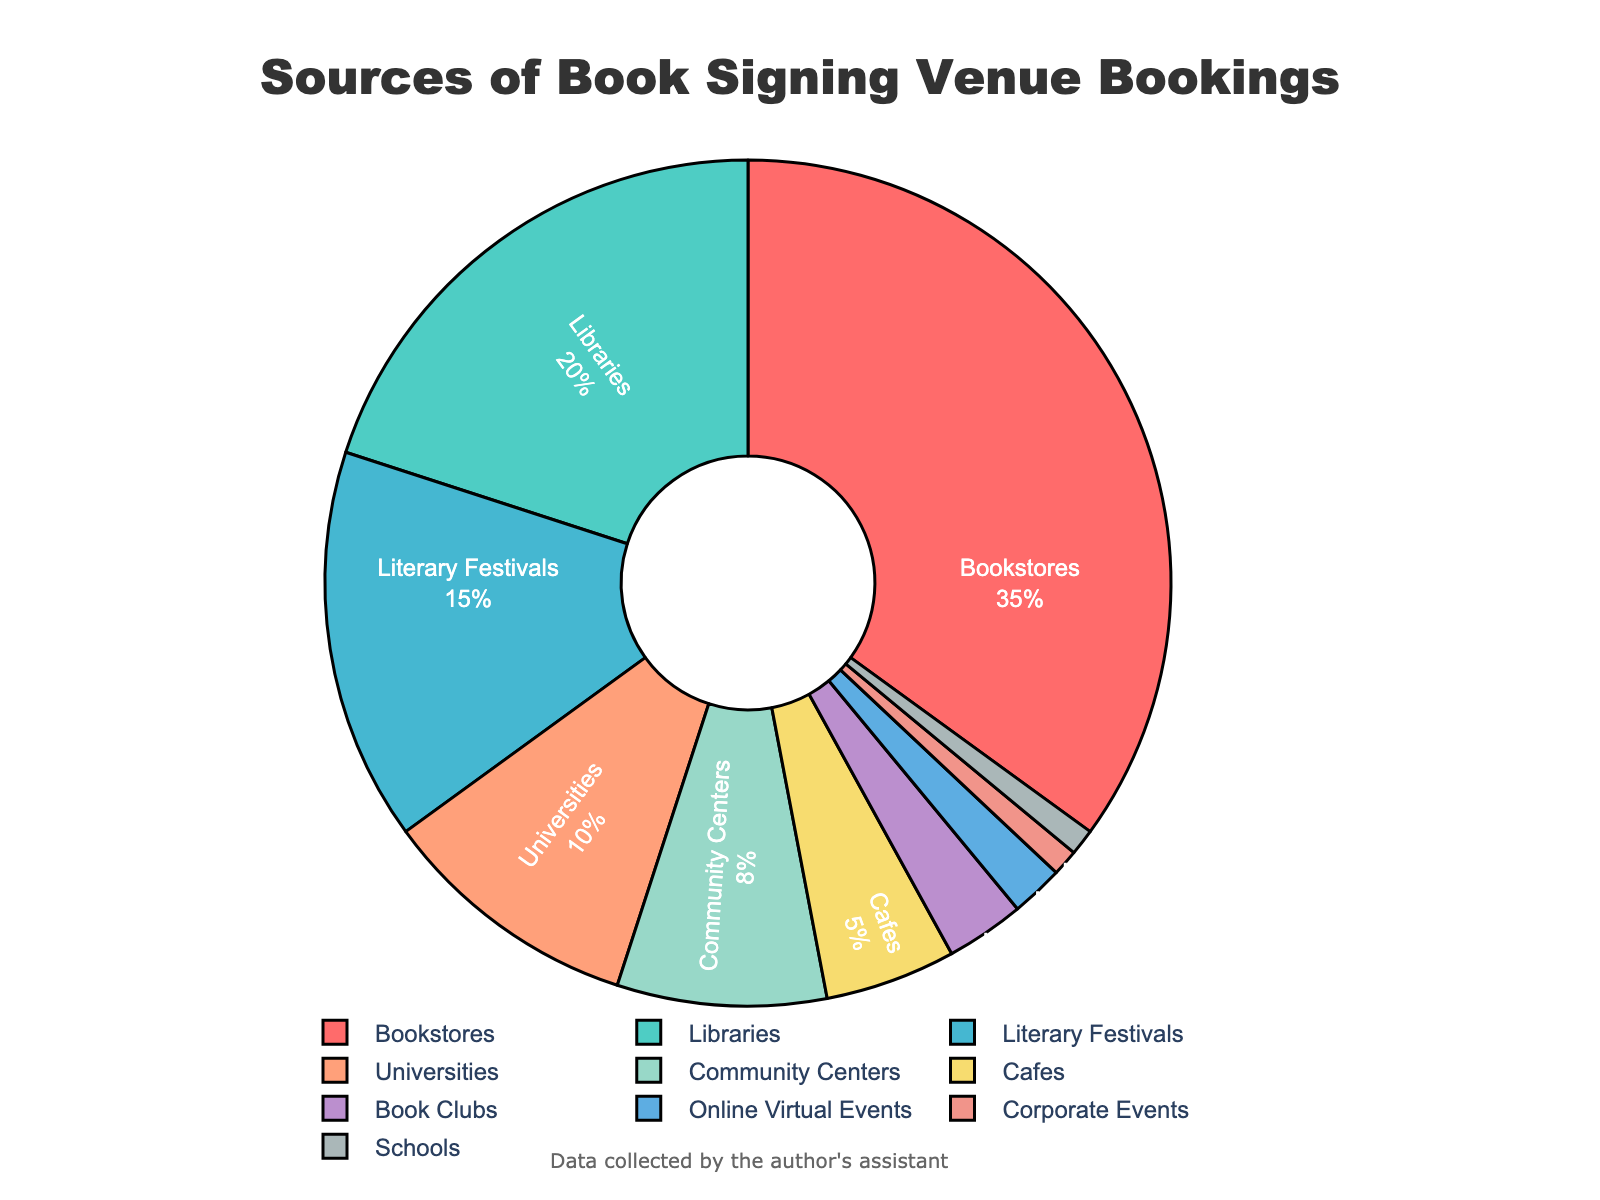What percentage of bookings is from libraries and community centers combined? Add the percentages for libraries (20%) and community centers (8%). 20 + 8 = 28
Answer: 28% Which source of venue bookings has the highest percentage? Look for the category with the largest percentage value; bookstores have the highest percentage at 35%.
Answer: Bookstores How does the percentage of bookings from literary festivals compare to those from universities? Compare the percentages for literary festivals (15%) and universities (10%); 15% is greater than 10%.
Answer: Literary festivals have a higher percentage Which category has the smallest share of venue bookings? Identify the category with the smallest percentage; corporate events and schools both have the smallest share at 1%.
Answer: Corporate events, Schools What is the combined percentage of bookings from cafes, book clubs, and online virtual events? Add the percentages for cafes (5%), book clubs (3%), and online virtual events (2%). 5 + 3 + 2 = 10
Answer: 10% Compare the total percentage of bookings from universities and schools to that from cafes. Add the percentages for universities (10%) and schools (1%) and compare to cafes (5%). 10 + 1 = 11, which is greater than 5.
Answer: Universities and schools combined have a higher percentage What type of venue does red color represent on the chart? The red color corresponds to the largest segment on the chart, which is bookstores with 35%.
Answer: Bookstores What is the difference in the percentage of bookings between literary festivals and community centers? Subtract the percentage for community centers (8%) from that of literary festivals (15%). 15 - 8 = 7
Answer: 7% How much more is the percentage of bookings from libraries compared to that from cafes? Subtract the percentage for cafes (5%) from that of libraries (20%). 20 - 5 = 15
Answer: 15% What percentage of bookings is accounted for by all categories other than bookstores? Subtract the percentage of bookstores (35%) from the total 100%. 100 - 35 = 65
Answer: 65% 